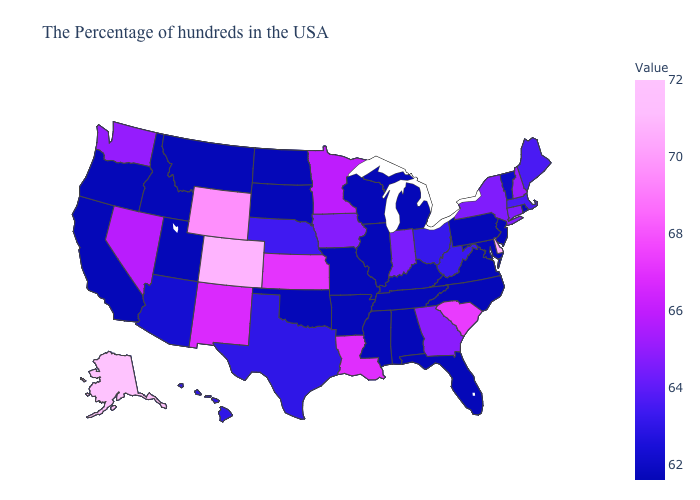Among the states that border Maine , which have the highest value?
Give a very brief answer. New Hampshire. Which states hav the highest value in the MidWest?
Give a very brief answer. Kansas. Does Maine have a lower value than Arizona?
Concise answer only. No. Among the states that border Iowa , which have the highest value?
Keep it brief. Minnesota. Does Oregon have the lowest value in the USA?
Write a very short answer. Yes. Which states have the highest value in the USA?
Give a very brief answer. Alaska. Which states hav the highest value in the South?
Short answer required. Delaware. Among the states that border Wisconsin , which have the highest value?
Be succinct. Minnesota. Does Minnesota have the highest value in the USA?
Be succinct. No. 